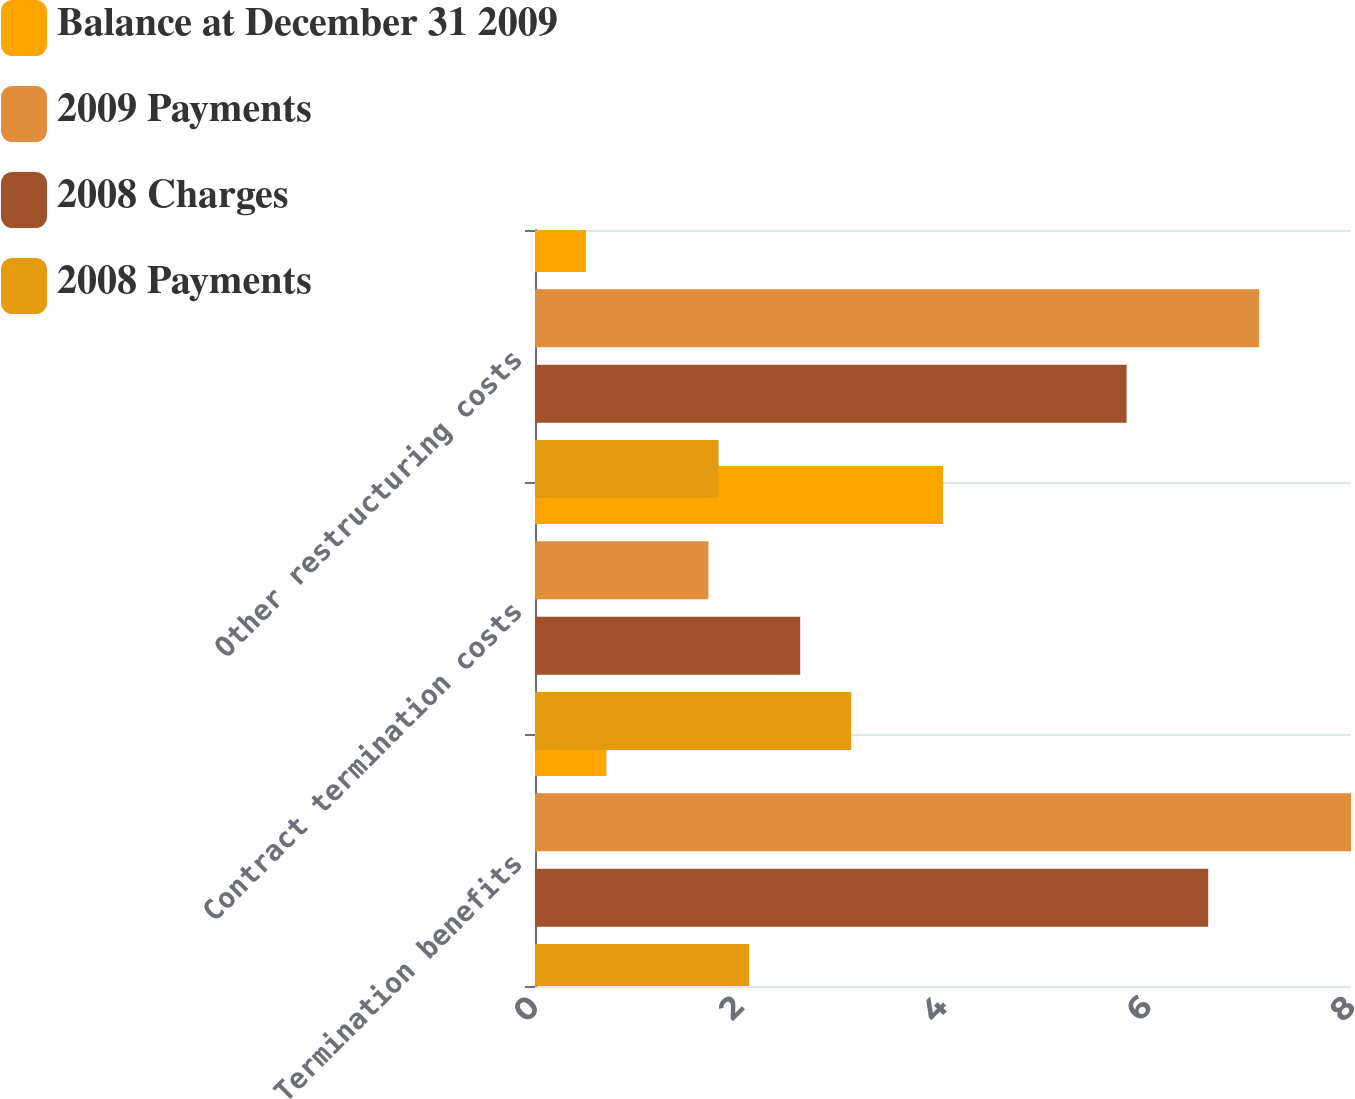Convert chart. <chart><loc_0><loc_0><loc_500><loc_500><stacked_bar_chart><ecel><fcel>Termination benefits<fcel>Contract termination costs<fcel>Other restructuring costs<nl><fcel>Balance at December 31 2009<fcel>0.7<fcel>4<fcel>0.5<nl><fcel>2009 Payments<fcel>8<fcel>1.7<fcel>7.1<nl><fcel>2008 Charges<fcel>6.6<fcel>2.6<fcel>5.8<nl><fcel>2008 Payments<fcel>2.1<fcel>3.1<fcel>1.8<nl></chart> 